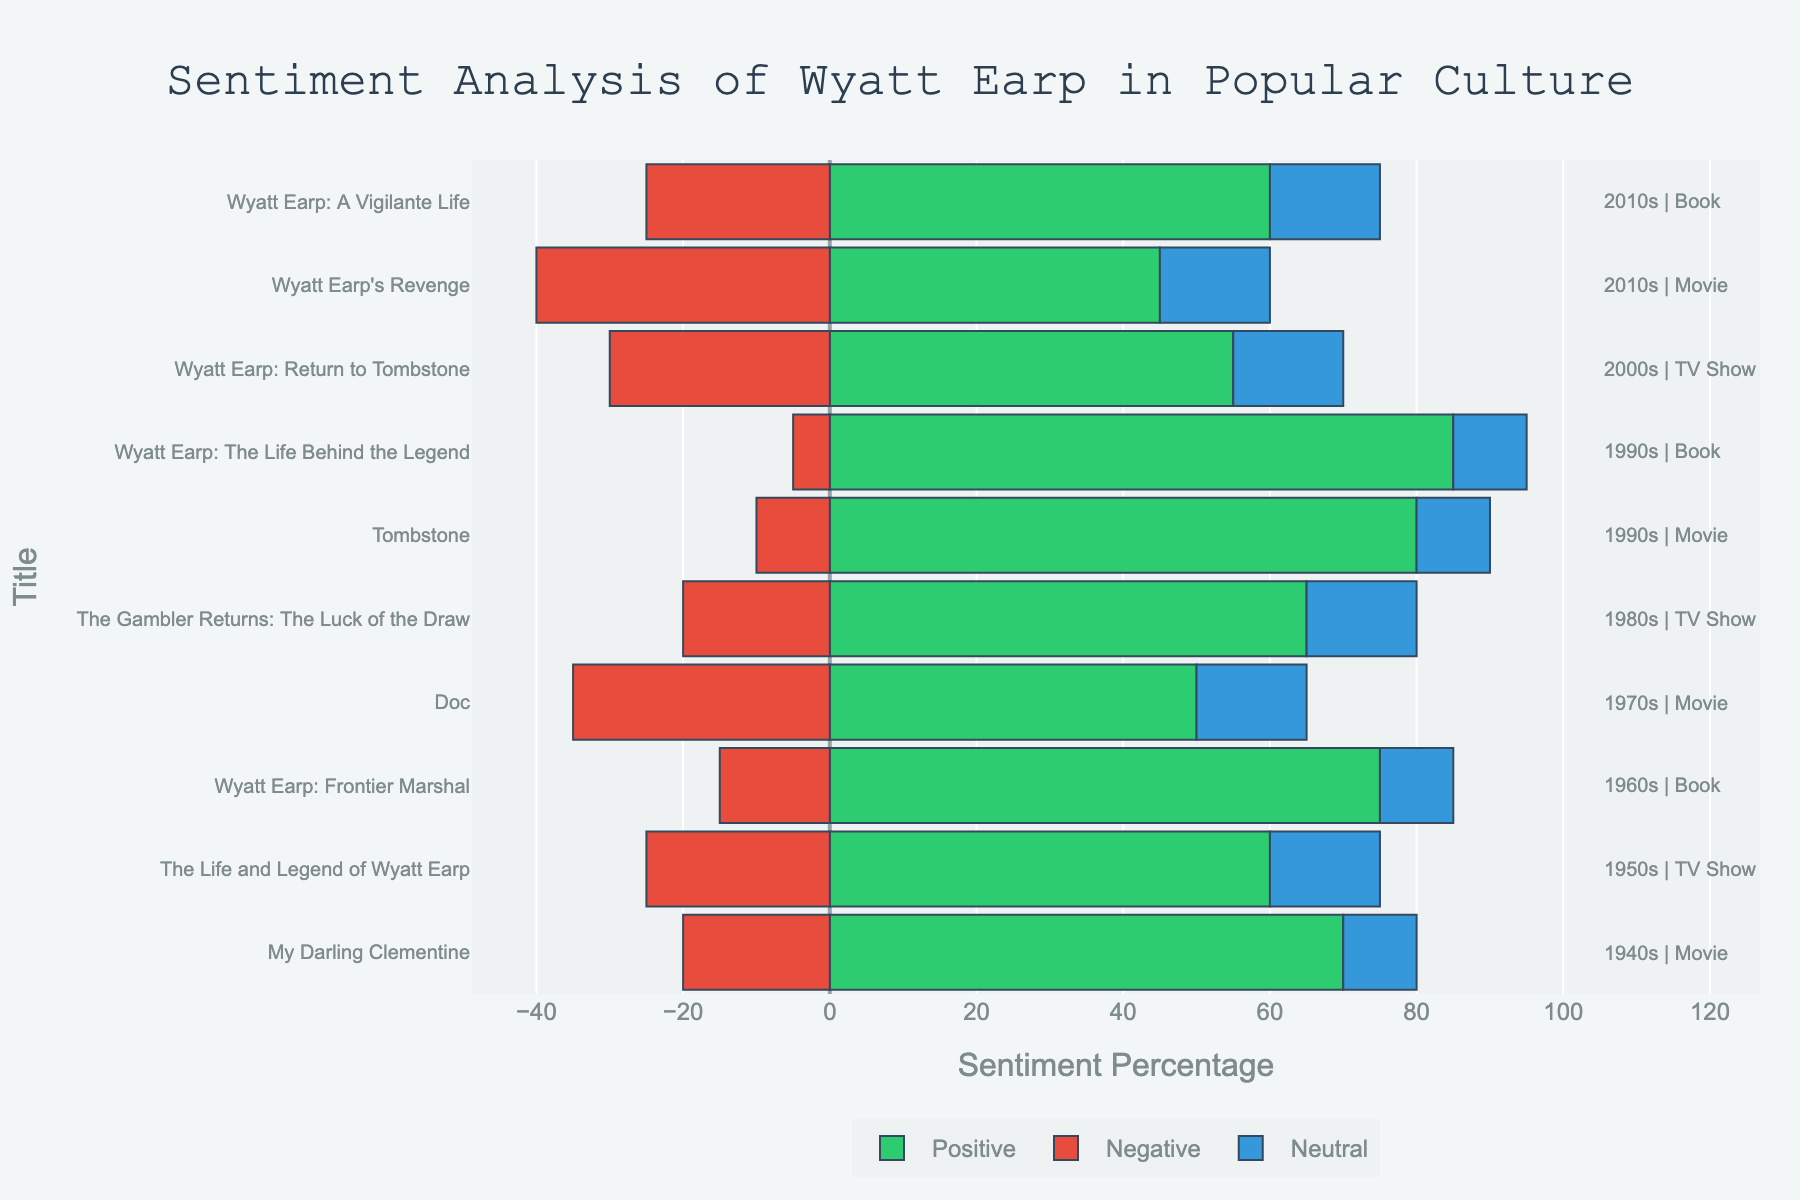What year does the movie with the highest positive sentiment come from? The movie with the highest positive sentiment is "Tombstone," which has an 80% positive sentiment. According to the annotations, "Tombstone" was released in the 1990s.
Answer: 1990s Which medium in the 2000s has the higher percentage of positive sentiment? There is only one entry in the 2000s: the TV Show "Wyatt Earp: Return to Tombstone," which has a 55% positive sentiment.
Answer: TV Show What is the average negative sentiment percentage across movies? The negative sentiment percentages for movies are 20%, 35%, 10%, and 40%. The average is (20 + 35 + 10 + 40) / 4 = 26.25%.
Answer: 26.25% Which title has the highest neutral sentiment? By visually inspecting the lengths of the neutral sentiment bars, all titles have equally long neutral sentiment bars of 10% or 15%. Neutral sentiment is not the highest for any single title.
Answer: None Compare the positive sentiment in movies of the 1940s and 2010s. Which decade has a higher percentage? The positive sentiment for the 1940s movie "My Darling Clementine" is 70%, while the 2010s movie "Wyatt Earp's Revenge" has a positive sentiment of 45%. The 1940s movie has a higher positive sentiment.
Answer: 1940s What is the total sentiment percentage for the book "Wyatt Earp: The Life Behind the Legend"? For the book "Wyatt Earp: The Life Behind the Legend," the positive sentiment is 85%, the negative sentiment is 5%, and the neutral sentiment is 10%. The total is 85 + 5 + 10 = 100%.
Answer: 100% Which title in the 1980s has a higher negative sentiment percentage than its positive sentiment percentage? The TV Show "The Gambler Returns: The Luck of the Draw" in the 1980s has 20% negative sentiment and 65% positive sentiment. Thus, its negative sentiment is not higher than its positive sentiment.
Answer: None What is the sentiment spread (difference between highest and lowest sentiment percentage) in the movie "Doc"? For "Doc," the positive sentiment is 50%, the negative sentiment is 35%, and the neutral sentiment is 15%. The spread is max(50, 35, 15) - min(50, 35, 15) = 50 - 15 = 35%.
Answer: 35% How does the positive sentiment in books compare between the 1960s and 1990s? The positive sentiment in the 1960s book "Wyatt Earp: Frontier Marshal" is 75%, while in the 1990s book "Wyatt Earp: The Life Behind the Legend," it is 85%. Thus, the 1990s book has a higher positive sentiment.
Answer: 1990s Which decade shows the most balanced sentiment percentages for Wyatt Earp's character? Analyzing the bars, the 1950s TV Show "The Life and Legend of Wyatt Earp" has the most balanced appearance with 60% positive, 25% negative, and 15% neutral. All sentiments add up evenly compared to other entries.
Answer: 1950s 